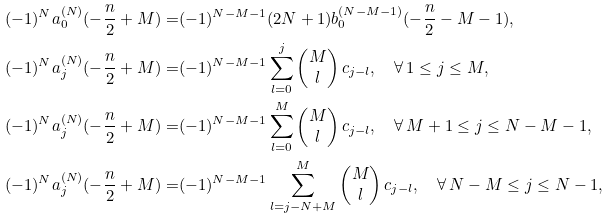Convert formula to latex. <formula><loc_0><loc_0><loc_500><loc_500>( - 1 ) ^ { N } a _ { 0 } ^ { ( N ) } ( - \frac { n } { 2 } + M ) = & ( - 1 ) ^ { N - M - 1 } ( 2 N + 1 ) b _ { 0 } ^ { ( N - M - 1 ) } ( - \frac { n } { 2 } - M - 1 ) , \\ ( - 1 ) ^ { N } a _ { j } ^ { ( N ) } ( - \frac { n } { 2 } + M ) = & ( - 1 ) ^ { N - M - 1 } \sum _ { l = 0 } ^ { j } \begin{pmatrix} M \\ l \end{pmatrix} c _ { j - l } , \quad \forall \, 1 \leq j \leq M , \\ ( - 1 ) ^ { N } a _ { j } ^ { ( N ) } ( - \frac { n } { 2 } + M ) = & ( - 1 ) ^ { N - M - 1 } \sum _ { l = 0 } ^ { M } \begin{pmatrix} M \\ l \end{pmatrix} c _ { j - l } , \quad \forall \, M + 1 \leq j \leq N - M - 1 , \\ ( - 1 ) ^ { N } a _ { j } ^ { ( N ) } ( - \frac { n } { 2 } + M ) = & ( - 1 ) ^ { N - M - 1 } \sum _ { l = j - N + M } ^ { M } \begin{pmatrix} M \\ l \end{pmatrix} c _ { j - l } , \quad \forall \, N - M \leq j \leq N - 1 ,</formula> 